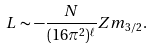<formula> <loc_0><loc_0><loc_500><loc_500>L \sim - \frac { N } { ( 1 6 \pi ^ { 2 } ) ^ { \ell } } Z m _ { 3 / 2 } .</formula> 